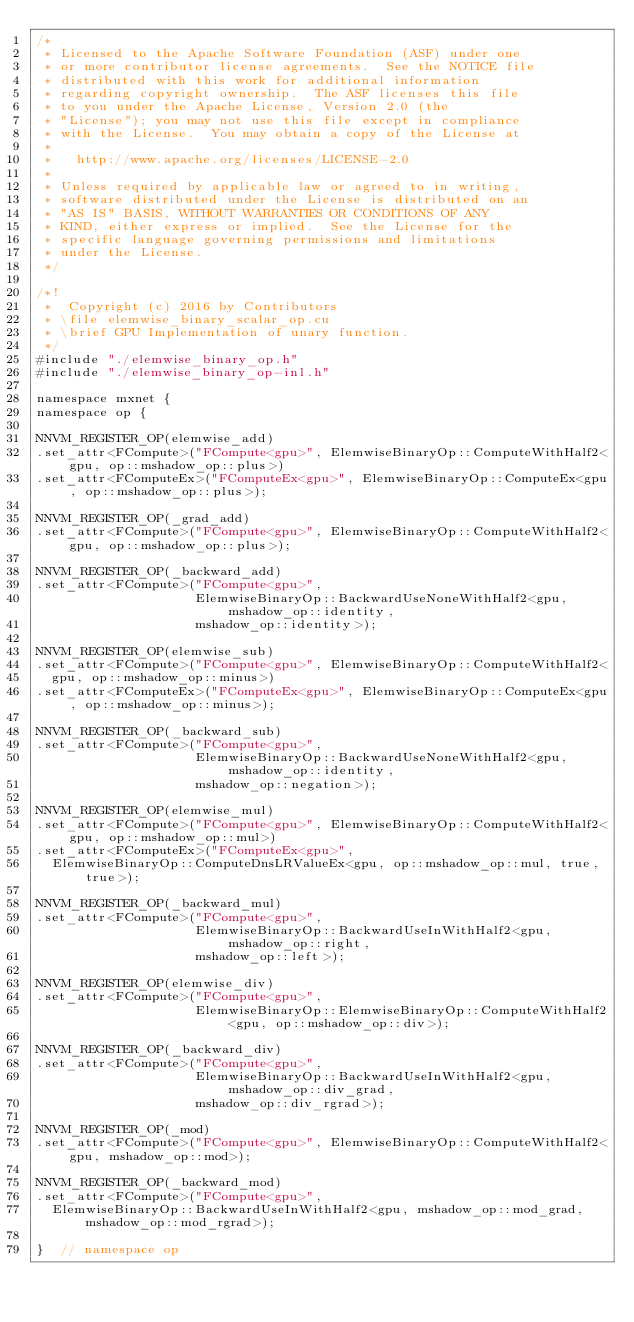<code> <loc_0><loc_0><loc_500><loc_500><_Cuda_>/*
 * Licensed to the Apache Software Foundation (ASF) under one
 * or more contributor license agreements.  See the NOTICE file
 * distributed with this work for additional information
 * regarding copyright ownership.  The ASF licenses this file
 * to you under the Apache License, Version 2.0 (the
 * "License"); you may not use this file except in compliance
 * with the License.  You may obtain a copy of the License at
 *
 *   http://www.apache.org/licenses/LICENSE-2.0
 *
 * Unless required by applicable law or agreed to in writing,
 * software distributed under the License is distributed on an
 * "AS IS" BASIS, WITHOUT WARRANTIES OR CONDITIONS OF ANY
 * KIND, either express or implied.  See the License for the
 * specific language governing permissions and limitations
 * under the License.
 */

/*!
 *  Copyright (c) 2016 by Contributors
 * \file elemwise_binary_scalar_op.cu
 * \brief GPU Implementation of unary function.
 */
#include "./elemwise_binary_op.h"
#include "./elemwise_binary_op-inl.h"

namespace mxnet {
namespace op {

NNVM_REGISTER_OP(elemwise_add)
.set_attr<FCompute>("FCompute<gpu>", ElemwiseBinaryOp::ComputeWithHalf2<gpu, op::mshadow_op::plus>)
.set_attr<FComputeEx>("FComputeEx<gpu>", ElemwiseBinaryOp::ComputeEx<gpu, op::mshadow_op::plus>);

NNVM_REGISTER_OP(_grad_add)
.set_attr<FCompute>("FCompute<gpu>", ElemwiseBinaryOp::ComputeWithHalf2<gpu, op::mshadow_op::plus>);

NNVM_REGISTER_OP(_backward_add)
.set_attr<FCompute>("FCompute<gpu>",
                    ElemwiseBinaryOp::BackwardUseNoneWithHalf2<gpu, mshadow_op::identity,
                    mshadow_op::identity>);

NNVM_REGISTER_OP(elemwise_sub)
.set_attr<FCompute>("FCompute<gpu>", ElemwiseBinaryOp::ComputeWithHalf2<
  gpu, op::mshadow_op::minus>)
.set_attr<FComputeEx>("FComputeEx<gpu>", ElemwiseBinaryOp::ComputeEx<gpu, op::mshadow_op::minus>);

NNVM_REGISTER_OP(_backward_sub)
.set_attr<FCompute>("FCompute<gpu>",
                    ElemwiseBinaryOp::BackwardUseNoneWithHalf2<gpu, mshadow_op::identity,
                    mshadow_op::negation>);

NNVM_REGISTER_OP(elemwise_mul)
.set_attr<FCompute>("FCompute<gpu>", ElemwiseBinaryOp::ComputeWithHalf2<gpu, op::mshadow_op::mul>)
.set_attr<FComputeEx>("FComputeEx<gpu>",
  ElemwiseBinaryOp::ComputeDnsLRValueEx<gpu, op::mshadow_op::mul, true, true>);

NNVM_REGISTER_OP(_backward_mul)
.set_attr<FCompute>("FCompute<gpu>",
                    ElemwiseBinaryOp::BackwardUseInWithHalf2<gpu, mshadow_op::right,
                    mshadow_op::left>);

NNVM_REGISTER_OP(elemwise_div)
.set_attr<FCompute>("FCompute<gpu>",
                    ElemwiseBinaryOp::ElemwiseBinaryOp::ComputeWithHalf2<gpu, op::mshadow_op::div>);

NNVM_REGISTER_OP(_backward_div)
.set_attr<FCompute>("FCompute<gpu>",
                    ElemwiseBinaryOp::BackwardUseInWithHalf2<gpu, mshadow_op::div_grad,
                    mshadow_op::div_rgrad>);

NNVM_REGISTER_OP(_mod)
.set_attr<FCompute>("FCompute<gpu>", ElemwiseBinaryOp::ComputeWithHalf2<gpu, mshadow_op::mod>);

NNVM_REGISTER_OP(_backward_mod)
.set_attr<FCompute>("FCompute<gpu>",
  ElemwiseBinaryOp::BackwardUseInWithHalf2<gpu, mshadow_op::mod_grad, mshadow_op::mod_rgrad>);

}  // namespace op</code> 